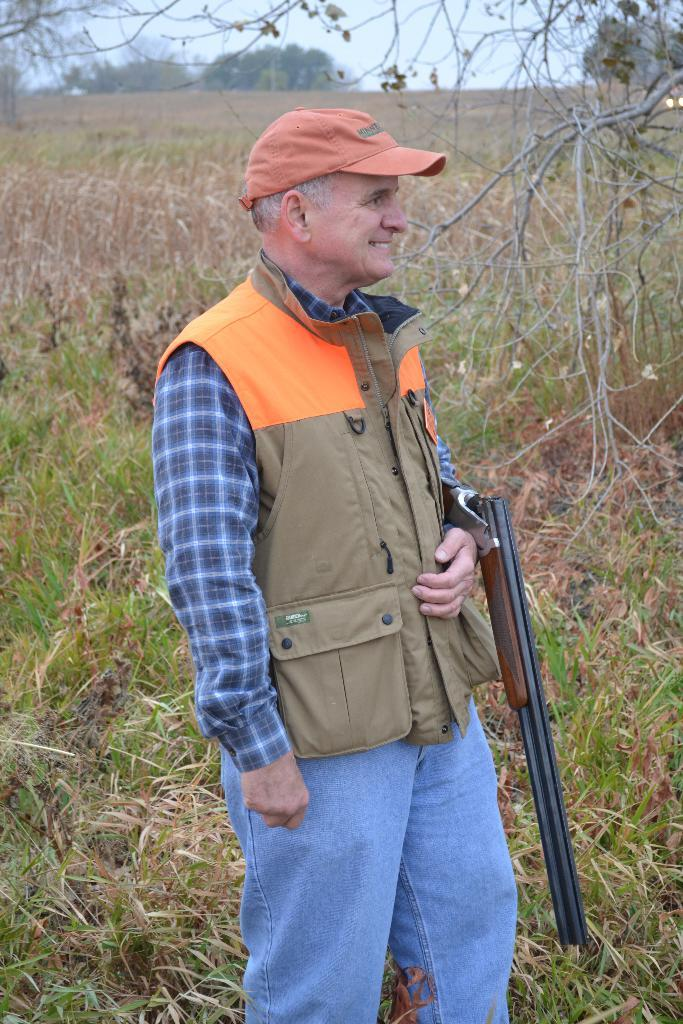What is the main subject of the image? The main subject of the image is a man standing. What is the man wearing in the image? The man is wearing clothes and a cap. What is the man's facial expression in the image? The man is smiling in the image. What is the man holding in the image? The man is holding a rifle in the image. What type of natural environment is visible in the image? There is grass, trees, and the sky visible in the image. How many cats are sitting on the man's finger in the image? There are no cats present in the image, and the man's finger is not visible. What type of card is the man holding in the image? The man is not holding a card in the image; he is holding a rifle. 